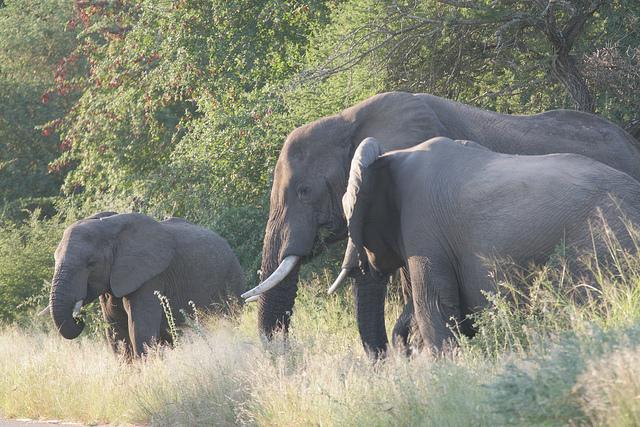How many baby elephants are there?
Keep it brief. 1. Where was this photo taken?
Short answer required. Africa. How well are the elephants able to hide?
Keep it brief. Not well. What are the elephants standing on?
Short answer required. Grass. How many elephants are in the picture?
Give a very brief answer. 3. How many elephants are in this photo?
Quick response, please. 3. 